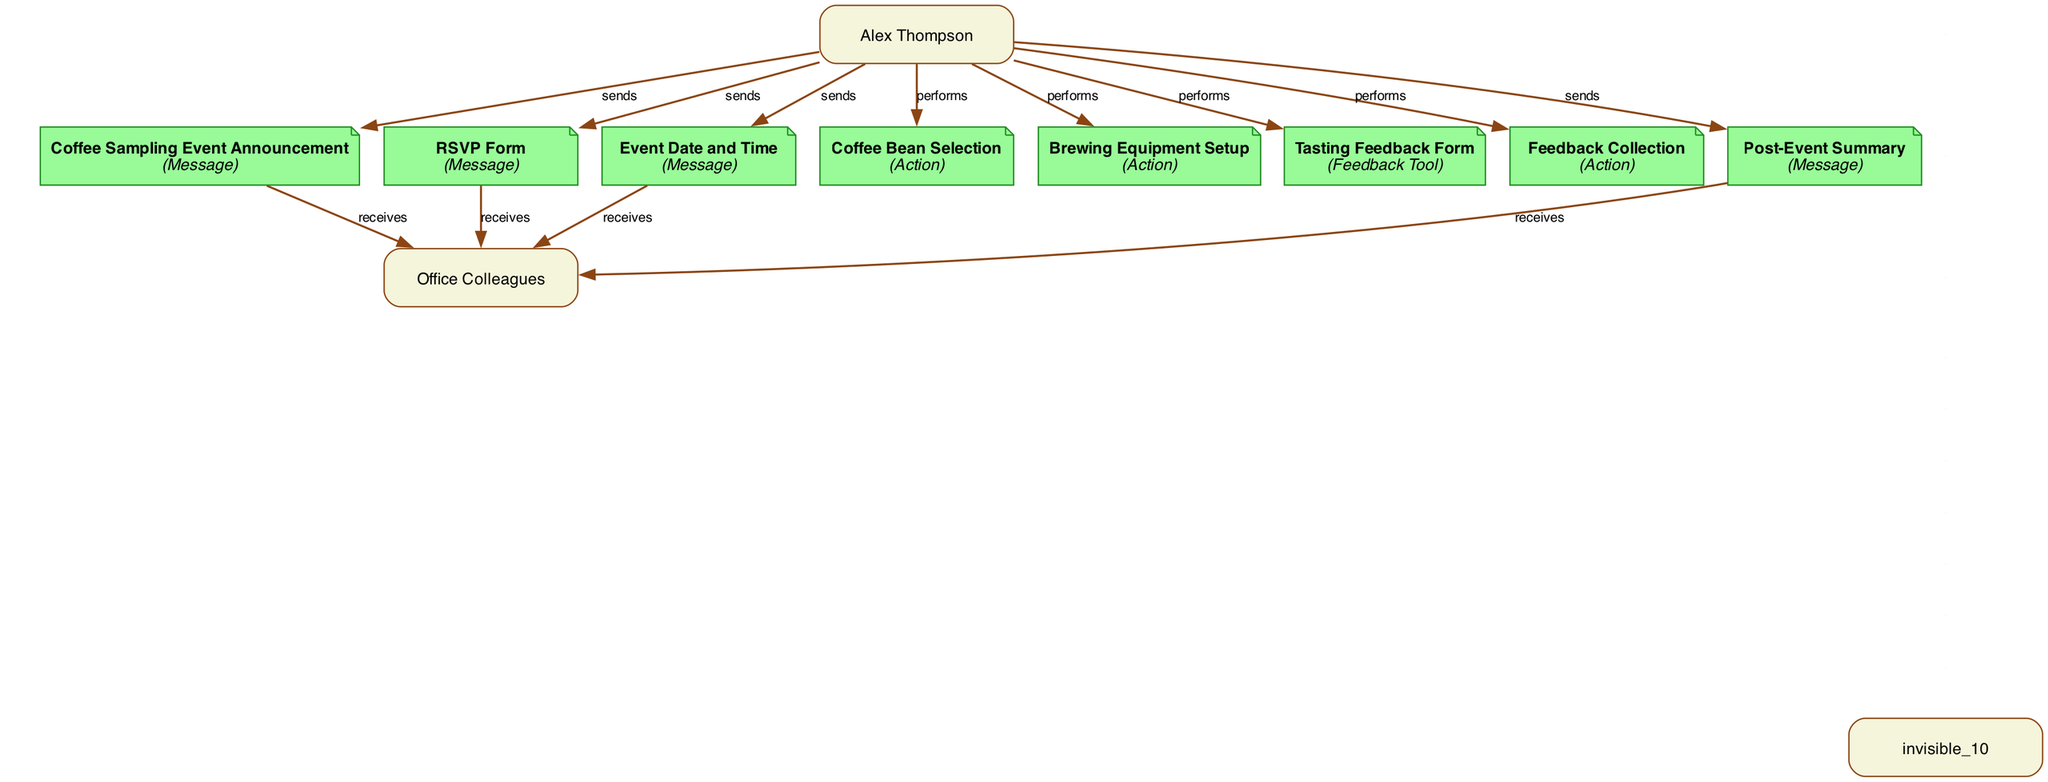What are the two participants involved in the office coffee tasting event? The diagram shows two participants: "Alex Thompson" and "Office Colleagues".
Answer: Alex Thompson, Office Colleagues How many messages are present in the diagram? The diagram contains five messages, which are "Coffee Sampling Event Announcement," "RSVP Form," "Event Date and Time," "Post-Event Summary," and one more. Counting these, we find five messages total.
Answer: 5 What action does Alex Thompson perform after sending the event announcement? After sending the "Coffee Sampling Event Announcement," Alex Thompson performs the action "Coffee Bean Selection." This can be traced from the sequence of events in the diagram where the announcement is followed by the selection action.
Answer: Coffee Bean Selection What feedback tool does Alex Thompson utilize after the coffee tasting event? The feedback tool used by Alex Thompson for collecting feedback is the "Tasting Feedback Form." This is indicated in the diagram where the Tasting Feedback Form is listed as a separate element after the event's actions.
Answer: Tasting Feedback Form Which action follows the setting up of brewing equipment? The action that follows "Brewing Equipment Setup" is "Feedback Collection." By following the sequence in the diagram, we can see that feedback collection occurs directly after the brewing setup.
Answer: Feedback Collection What is the final output listed in the sequence? The final output in the sequence is the "Post-Event Summary." This is the last message noted in the diagram after all actions and feedback collection has taken place.
Answer: Post-Event Summary Which action is performed by Alex Thompson before collecting feedback? Before collecting feedback, Alex Thompson performs "Brewing Equipment Setup." This is recorded in the sequence leading up to the feedback collection stage.
Answer: Brewing Equipment Setup How many actions are included in the diagram? The diagram includes three actions: "Coffee Bean Selection," "Brewing Equipment Setup," and "Feedback Collection." Counting these elements gives a total of three actions.
Answer: 3 What relationship do Alex Thompson and Office Colleagues have in the context of the event? Alex Thompson is the sender of the messages and the performer of actions, while Office Colleagues receive the messages and participate in the tasting. This creates a relationship of organizer to participants in the context of the event.
Answer: Organizer to Participants 